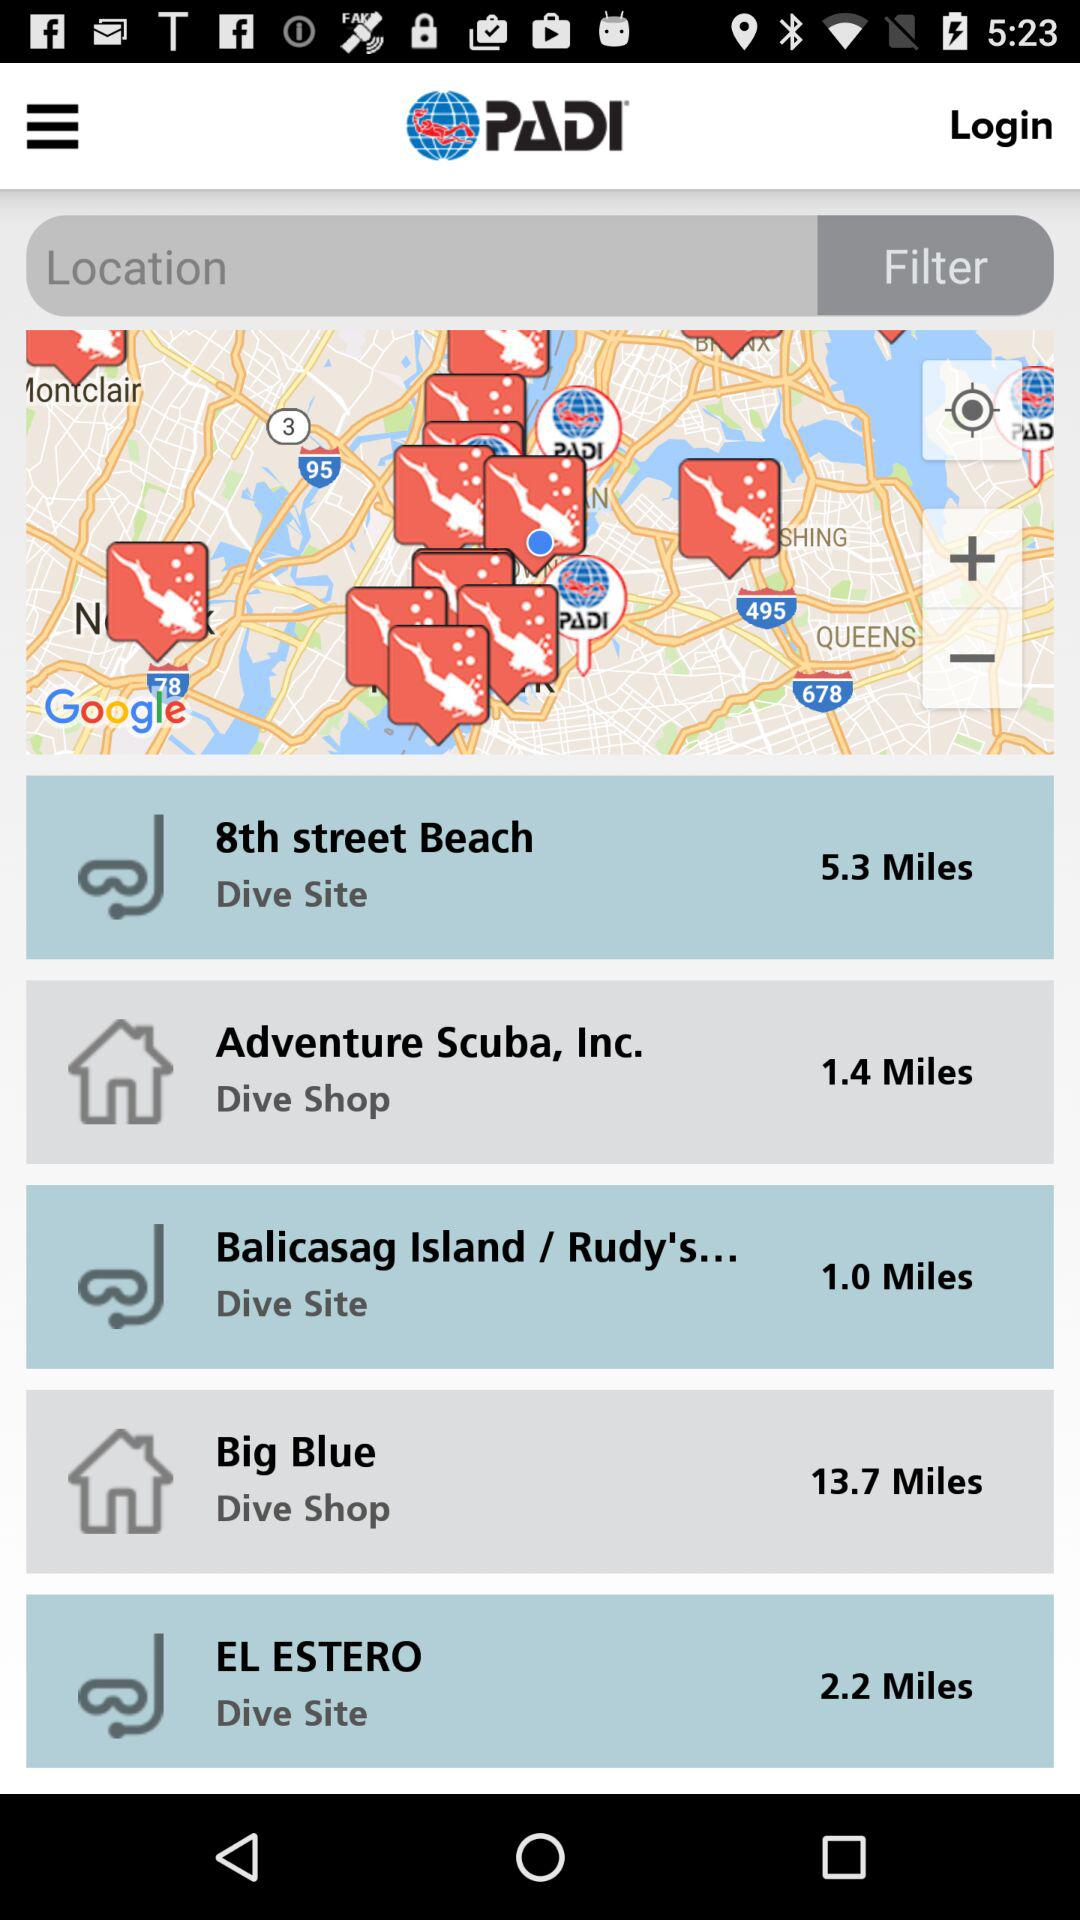What is the application name? The application name is "PADI". 